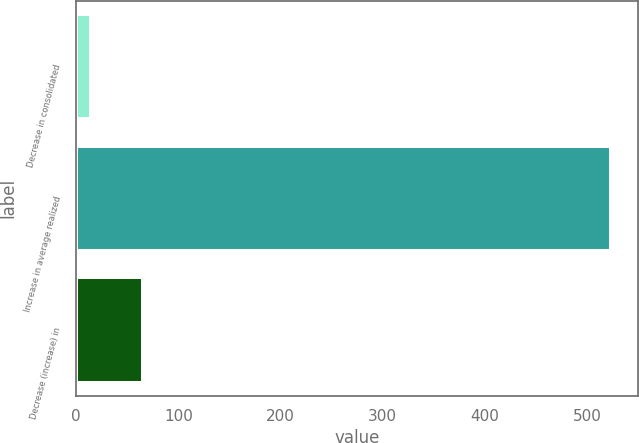Convert chart to OTSL. <chart><loc_0><loc_0><loc_500><loc_500><bar_chart><fcel>Decrease in consolidated<fcel>Increase in average realized<fcel>Decrease (increase) in<nl><fcel>15<fcel>524<fcel>65.9<nl></chart> 